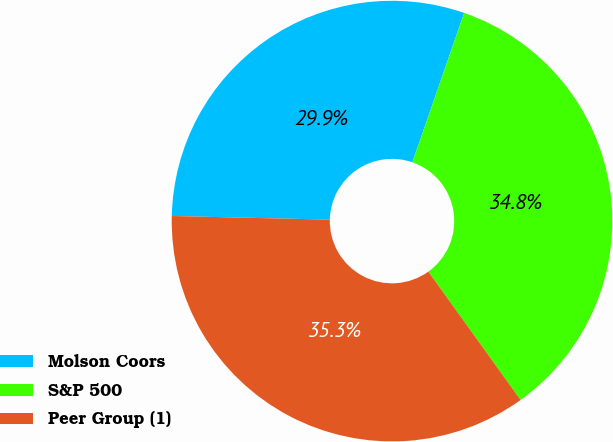Convert chart to OTSL. <chart><loc_0><loc_0><loc_500><loc_500><pie_chart><fcel>Molson Coors<fcel>S&P 500<fcel>Peer Group (1)<nl><fcel>29.94%<fcel>34.77%<fcel>35.29%<nl></chart> 